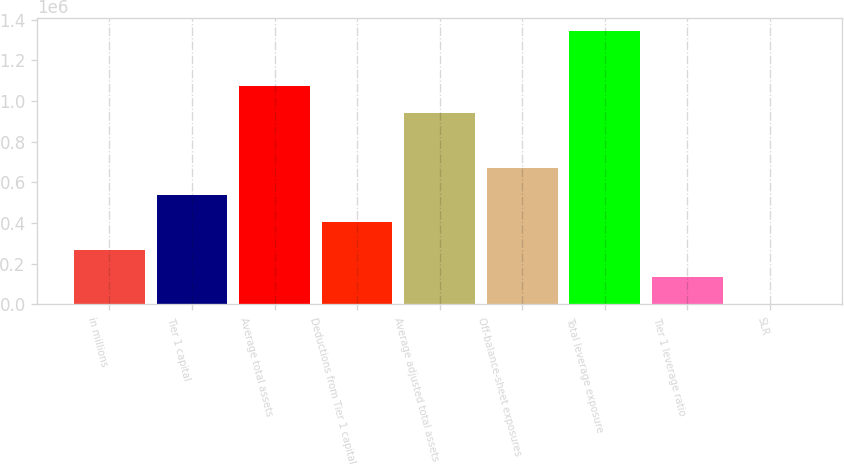<chart> <loc_0><loc_0><loc_500><loc_500><bar_chart><fcel>in millions<fcel>Tier 1 capital<fcel>Average total assets<fcel>Deductions from Tier 1 capital<fcel>Average adjusted total assets<fcel>Off-balance-sheet exposures<fcel>Total leverage exposure<fcel>Tier 1 leverage ratio<fcel>SLR<nl><fcel>268586<fcel>537166<fcel>1.0755e+06<fcel>402876<fcel>941207<fcel>671456<fcel>1.34291e+06<fcel>134296<fcel>6.2<nl></chart> 